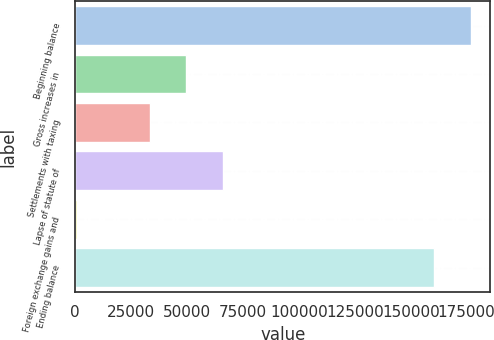<chart> <loc_0><loc_0><loc_500><loc_500><bar_chart><fcel>Beginning balance<fcel>Gross increases in<fcel>Settlements with taxing<fcel>Lapse of statute of<fcel>Foreign exchange gains and<fcel>Ending balance<nl><fcel>176748<fcel>49647<fcel>33367<fcel>65927<fcel>807<fcel>160468<nl></chart> 